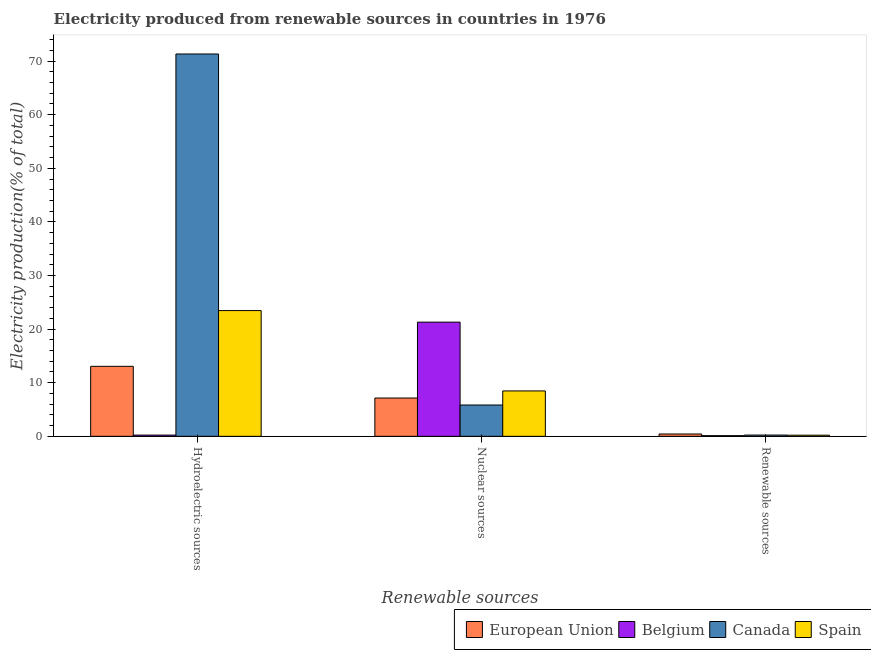How many groups of bars are there?
Provide a short and direct response. 3. Are the number of bars per tick equal to the number of legend labels?
Your response must be concise. Yes. How many bars are there on the 2nd tick from the left?
Your answer should be compact. 4. How many bars are there on the 2nd tick from the right?
Your response must be concise. 4. What is the label of the 3rd group of bars from the left?
Your answer should be very brief. Renewable sources. What is the percentage of electricity produced by renewable sources in Belgium?
Offer a terse response. 0.12. Across all countries, what is the maximum percentage of electricity produced by hydroelectric sources?
Your response must be concise. 71.32. Across all countries, what is the minimum percentage of electricity produced by renewable sources?
Your answer should be very brief. 0.12. In which country was the percentage of electricity produced by nuclear sources minimum?
Give a very brief answer. Canada. What is the total percentage of electricity produced by hydroelectric sources in the graph?
Provide a succinct answer. 108.06. What is the difference between the percentage of electricity produced by renewable sources in Canada and that in Belgium?
Your answer should be very brief. 0.12. What is the difference between the percentage of electricity produced by renewable sources in Spain and the percentage of electricity produced by hydroelectric sources in European Union?
Your answer should be compact. -12.85. What is the average percentage of electricity produced by hydroelectric sources per country?
Offer a terse response. 27.02. What is the difference between the percentage of electricity produced by hydroelectric sources and percentage of electricity produced by renewable sources in Canada?
Provide a succinct answer. 71.08. What is the ratio of the percentage of electricity produced by hydroelectric sources in Belgium to that in Spain?
Give a very brief answer. 0.01. What is the difference between the highest and the second highest percentage of electricity produced by hydroelectric sources?
Make the answer very short. 47.86. What is the difference between the highest and the lowest percentage of electricity produced by hydroelectric sources?
Ensure brevity in your answer.  71.09. Is the sum of the percentage of electricity produced by renewable sources in Canada and European Union greater than the maximum percentage of electricity produced by hydroelectric sources across all countries?
Your answer should be compact. No. What does the 4th bar from the right in Hydroelectric sources represents?
Provide a short and direct response. European Union. Is it the case that in every country, the sum of the percentage of electricity produced by hydroelectric sources and percentage of electricity produced by nuclear sources is greater than the percentage of electricity produced by renewable sources?
Your response must be concise. Yes. How many countries are there in the graph?
Ensure brevity in your answer.  4. Does the graph contain grids?
Provide a succinct answer. No. How are the legend labels stacked?
Your answer should be compact. Horizontal. What is the title of the graph?
Keep it short and to the point. Electricity produced from renewable sources in countries in 1976. What is the label or title of the X-axis?
Your answer should be compact. Renewable sources. What is the Electricity production(% of total) in European Union in Hydroelectric sources?
Give a very brief answer. 13.06. What is the Electricity production(% of total) in Belgium in Hydroelectric sources?
Ensure brevity in your answer.  0.23. What is the Electricity production(% of total) in Canada in Hydroelectric sources?
Your response must be concise. 71.32. What is the Electricity production(% of total) in Spain in Hydroelectric sources?
Provide a succinct answer. 23.45. What is the Electricity production(% of total) in European Union in Nuclear sources?
Make the answer very short. 7.14. What is the Electricity production(% of total) in Belgium in Nuclear sources?
Ensure brevity in your answer.  21.3. What is the Electricity production(% of total) in Canada in Nuclear sources?
Keep it short and to the point. 5.84. What is the Electricity production(% of total) in Spain in Nuclear sources?
Offer a terse response. 8.47. What is the Electricity production(% of total) of European Union in Renewable sources?
Make the answer very short. 0.43. What is the Electricity production(% of total) of Belgium in Renewable sources?
Keep it short and to the point. 0.12. What is the Electricity production(% of total) of Canada in Renewable sources?
Ensure brevity in your answer.  0.24. What is the Electricity production(% of total) in Spain in Renewable sources?
Make the answer very short. 0.21. Across all Renewable sources, what is the maximum Electricity production(% of total) of European Union?
Your answer should be compact. 13.06. Across all Renewable sources, what is the maximum Electricity production(% of total) in Belgium?
Offer a very short reply. 21.3. Across all Renewable sources, what is the maximum Electricity production(% of total) of Canada?
Your answer should be very brief. 71.32. Across all Renewable sources, what is the maximum Electricity production(% of total) of Spain?
Provide a short and direct response. 23.45. Across all Renewable sources, what is the minimum Electricity production(% of total) in European Union?
Provide a short and direct response. 0.43. Across all Renewable sources, what is the minimum Electricity production(% of total) in Belgium?
Keep it short and to the point. 0.12. Across all Renewable sources, what is the minimum Electricity production(% of total) in Canada?
Offer a terse response. 0.24. Across all Renewable sources, what is the minimum Electricity production(% of total) in Spain?
Offer a terse response. 0.21. What is the total Electricity production(% of total) of European Union in the graph?
Provide a short and direct response. 20.64. What is the total Electricity production(% of total) of Belgium in the graph?
Offer a terse response. 21.65. What is the total Electricity production(% of total) in Canada in the graph?
Offer a terse response. 77.4. What is the total Electricity production(% of total) of Spain in the graph?
Ensure brevity in your answer.  32.13. What is the difference between the Electricity production(% of total) of European Union in Hydroelectric sources and that in Nuclear sources?
Your response must be concise. 5.91. What is the difference between the Electricity production(% of total) in Belgium in Hydroelectric sources and that in Nuclear sources?
Give a very brief answer. -21.07. What is the difference between the Electricity production(% of total) in Canada in Hydroelectric sources and that in Nuclear sources?
Your answer should be compact. 65.48. What is the difference between the Electricity production(% of total) of Spain in Hydroelectric sources and that in Nuclear sources?
Offer a terse response. 14.99. What is the difference between the Electricity production(% of total) of European Union in Hydroelectric sources and that in Renewable sources?
Offer a terse response. 12.62. What is the difference between the Electricity production(% of total) in Belgium in Hydroelectric sources and that in Renewable sources?
Provide a succinct answer. 0.11. What is the difference between the Electricity production(% of total) of Canada in Hydroelectric sources and that in Renewable sources?
Make the answer very short. 71.08. What is the difference between the Electricity production(% of total) in Spain in Hydroelectric sources and that in Renewable sources?
Keep it short and to the point. 23.25. What is the difference between the Electricity production(% of total) in European Union in Nuclear sources and that in Renewable sources?
Keep it short and to the point. 6.71. What is the difference between the Electricity production(% of total) of Belgium in Nuclear sources and that in Renewable sources?
Your answer should be compact. 21.18. What is the difference between the Electricity production(% of total) of Canada in Nuclear sources and that in Renewable sources?
Provide a succinct answer. 5.6. What is the difference between the Electricity production(% of total) of Spain in Nuclear sources and that in Renewable sources?
Make the answer very short. 8.26. What is the difference between the Electricity production(% of total) of European Union in Hydroelectric sources and the Electricity production(% of total) of Belgium in Nuclear sources?
Provide a short and direct response. -8.24. What is the difference between the Electricity production(% of total) of European Union in Hydroelectric sources and the Electricity production(% of total) of Canada in Nuclear sources?
Your answer should be compact. 7.22. What is the difference between the Electricity production(% of total) of European Union in Hydroelectric sources and the Electricity production(% of total) of Spain in Nuclear sources?
Give a very brief answer. 4.59. What is the difference between the Electricity production(% of total) in Belgium in Hydroelectric sources and the Electricity production(% of total) in Canada in Nuclear sources?
Your answer should be very brief. -5.61. What is the difference between the Electricity production(% of total) of Belgium in Hydroelectric sources and the Electricity production(% of total) of Spain in Nuclear sources?
Your answer should be very brief. -8.23. What is the difference between the Electricity production(% of total) of Canada in Hydroelectric sources and the Electricity production(% of total) of Spain in Nuclear sources?
Provide a succinct answer. 62.85. What is the difference between the Electricity production(% of total) in European Union in Hydroelectric sources and the Electricity production(% of total) in Belgium in Renewable sources?
Ensure brevity in your answer.  12.94. What is the difference between the Electricity production(% of total) of European Union in Hydroelectric sources and the Electricity production(% of total) of Canada in Renewable sources?
Your response must be concise. 12.82. What is the difference between the Electricity production(% of total) of European Union in Hydroelectric sources and the Electricity production(% of total) of Spain in Renewable sources?
Keep it short and to the point. 12.85. What is the difference between the Electricity production(% of total) in Belgium in Hydroelectric sources and the Electricity production(% of total) in Canada in Renewable sources?
Keep it short and to the point. -0.01. What is the difference between the Electricity production(% of total) of Belgium in Hydroelectric sources and the Electricity production(% of total) of Spain in Renewable sources?
Give a very brief answer. 0.02. What is the difference between the Electricity production(% of total) of Canada in Hydroelectric sources and the Electricity production(% of total) of Spain in Renewable sources?
Provide a succinct answer. 71.11. What is the difference between the Electricity production(% of total) of European Union in Nuclear sources and the Electricity production(% of total) of Belgium in Renewable sources?
Your answer should be very brief. 7.02. What is the difference between the Electricity production(% of total) of European Union in Nuclear sources and the Electricity production(% of total) of Canada in Renewable sources?
Keep it short and to the point. 6.91. What is the difference between the Electricity production(% of total) of European Union in Nuclear sources and the Electricity production(% of total) of Spain in Renewable sources?
Your answer should be compact. 6.93. What is the difference between the Electricity production(% of total) in Belgium in Nuclear sources and the Electricity production(% of total) in Canada in Renewable sources?
Keep it short and to the point. 21.06. What is the difference between the Electricity production(% of total) in Belgium in Nuclear sources and the Electricity production(% of total) in Spain in Renewable sources?
Keep it short and to the point. 21.09. What is the difference between the Electricity production(% of total) in Canada in Nuclear sources and the Electricity production(% of total) in Spain in Renewable sources?
Offer a terse response. 5.63. What is the average Electricity production(% of total) in European Union per Renewable sources?
Keep it short and to the point. 6.88. What is the average Electricity production(% of total) in Belgium per Renewable sources?
Keep it short and to the point. 7.22. What is the average Electricity production(% of total) in Canada per Renewable sources?
Ensure brevity in your answer.  25.8. What is the average Electricity production(% of total) of Spain per Renewable sources?
Your answer should be very brief. 10.71. What is the difference between the Electricity production(% of total) of European Union and Electricity production(% of total) of Belgium in Hydroelectric sources?
Make the answer very short. 12.83. What is the difference between the Electricity production(% of total) of European Union and Electricity production(% of total) of Canada in Hydroelectric sources?
Keep it short and to the point. -58.26. What is the difference between the Electricity production(% of total) in European Union and Electricity production(% of total) in Spain in Hydroelectric sources?
Your answer should be very brief. -10.4. What is the difference between the Electricity production(% of total) of Belgium and Electricity production(% of total) of Canada in Hydroelectric sources?
Your response must be concise. -71.09. What is the difference between the Electricity production(% of total) in Belgium and Electricity production(% of total) in Spain in Hydroelectric sources?
Make the answer very short. -23.22. What is the difference between the Electricity production(% of total) in Canada and Electricity production(% of total) in Spain in Hydroelectric sources?
Offer a very short reply. 47.87. What is the difference between the Electricity production(% of total) of European Union and Electricity production(% of total) of Belgium in Nuclear sources?
Your response must be concise. -14.15. What is the difference between the Electricity production(% of total) in European Union and Electricity production(% of total) in Canada in Nuclear sources?
Give a very brief answer. 1.3. What is the difference between the Electricity production(% of total) of European Union and Electricity production(% of total) of Spain in Nuclear sources?
Keep it short and to the point. -1.32. What is the difference between the Electricity production(% of total) of Belgium and Electricity production(% of total) of Canada in Nuclear sources?
Your answer should be very brief. 15.46. What is the difference between the Electricity production(% of total) in Belgium and Electricity production(% of total) in Spain in Nuclear sources?
Provide a short and direct response. 12.83. What is the difference between the Electricity production(% of total) of Canada and Electricity production(% of total) of Spain in Nuclear sources?
Make the answer very short. -2.63. What is the difference between the Electricity production(% of total) of European Union and Electricity production(% of total) of Belgium in Renewable sources?
Keep it short and to the point. 0.31. What is the difference between the Electricity production(% of total) in European Union and Electricity production(% of total) in Canada in Renewable sources?
Provide a succinct answer. 0.2. What is the difference between the Electricity production(% of total) of European Union and Electricity production(% of total) of Spain in Renewable sources?
Your answer should be compact. 0.23. What is the difference between the Electricity production(% of total) in Belgium and Electricity production(% of total) in Canada in Renewable sources?
Provide a succinct answer. -0.12. What is the difference between the Electricity production(% of total) of Belgium and Electricity production(% of total) of Spain in Renewable sources?
Keep it short and to the point. -0.09. What is the difference between the Electricity production(% of total) in Canada and Electricity production(% of total) in Spain in Renewable sources?
Your response must be concise. 0.03. What is the ratio of the Electricity production(% of total) in European Union in Hydroelectric sources to that in Nuclear sources?
Your answer should be very brief. 1.83. What is the ratio of the Electricity production(% of total) in Belgium in Hydroelectric sources to that in Nuclear sources?
Give a very brief answer. 0.01. What is the ratio of the Electricity production(% of total) in Canada in Hydroelectric sources to that in Nuclear sources?
Offer a terse response. 12.21. What is the ratio of the Electricity production(% of total) of Spain in Hydroelectric sources to that in Nuclear sources?
Offer a terse response. 2.77. What is the ratio of the Electricity production(% of total) of European Union in Hydroelectric sources to that in Renewable sources?
Keep it short and to the point. 30.05. What is the ratio of the Electricity production(% of total) in Belgium in Hydroelectric sources to that in Renewable sources?
Provide a succinct answer. 1.91. What is the ratio of the Electricity production(% of total) in Canada in Hydroelectric sources to that in Renewable sources?
Your answer should be compact. 300.83. What is the ratio of the Electricity production(% of total) in Spain in Hydroelectric sources to that in Renewable sources?
Your answer should be very brief. 111.94. What is the ratio of the Electricity production(% of total) of European Union in Nuclear sources to that in Renewable sources?
Keep it short and to the point. 16.44. What is the ratio of the Electricity production(% of total) of Belgium in Nuclear sources to that in Renewable sources?
Your response must be concise. 176.07. What is the ratio of the Electricity production(% of total) in Canada in Nuclear sources to that in Renewable sources?
Give a very brief answer. 24.63. What is the ratio of the Electricity production(% of total) in Spain in Nuclear sources to that in Renewable sources?
Make the answer very short. 40.4. What is the difference between the highest and the second highest Electricity production(% of total) of European Union?
Provide a short and direct response. 5.91. What is the difference between the highest and the second highest Electricity production(% of total) in Belgium?
Make the answer very short. 21.07. What is the difference between the highest and the second highest Electricity production(% of total) of Canada?
Ensure brevity in your answer.  65.48. What is the difference between the highest and the second highest Electricity production(% of total) of Spain?
Your answer should be very brief. 14.99. What is the difference between the highest and the lowest Electricity production(% of total) in European Union?
Your response must be concise. 12.62. What is the difference between the highest and the lowest Electricity production(% of total) in Belgium?
Your answer should be compact. 21.18. What is the difference between the highest and the lowest Electricity production(% of total) of Canada?
Ensure brevity in your answer.  71.08. What is the difference between the highest and the lowest Electricity production(% of total) of Spain?
Provide a succinct answer. 23.25. 